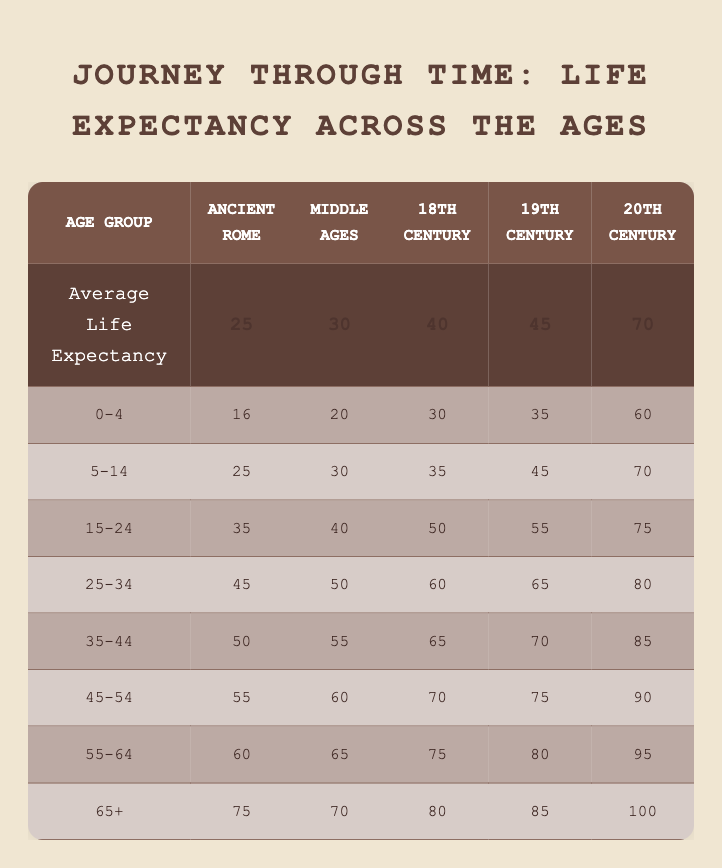What was the average life expectancy in the 20th century? The table states that the average life expectancy for the 20th century is 70.
Answer: 70 How long could someone expect to live at age 65 in the Middle Ages? According to the table, a person aged 65 and older in the Middle Ages had a life expectancy of 70 years.
Answer: 70 Which age group saw the largest increase in life expectancy from Ancient Rome to the 20th century? By comparing the values, the age group 65+ had a life expectancy of 75 in Ancient Rome and 100 in the 20th century. The increase is 100 - 75 = 25 years, which is the largest increase compared to other age groups.
Answer: 65+ What is the difference in life expectancy for the age group 5-14 between the 18th and 19th centuries? The life expectancy for the age group 5-14 is 35 in the 18th century and 45 in the 19th century. The difference is 45 - 35 = 10 years.
Answer: 10 Is the life expectancy for the age group 55-64 in the 19th century higher than that in the Middle Ages? The life expectancy for the age group 55-64 in the 19th century is 80, while in the Middle Ages it is 65. Since 80 is greater than 65, the statement is true.
Answer: Yes What is the average life expectancy across all periods for the age group 25-34? For this age group, the life expectancies are 45 (Ancient Rome), 50 (Middle Ages), 60 (18th century), 65 (19th century), and 80 (20th century). The average is (45 + 50 + 60 + 65 + 80) / 5 = 60.
Answer: 60 In which historical period did the 15-24 age group have a life expectancy closest to 50 years? The life expectancy for the 15-24 age group is 50 in the 18th century and 55 in the 19th century. Since 50 is the only value closest to 50, it corresponds to the 18th century.
Answer: 18th century What was the average life expectancy for individuals aged 0-4 across all historical periods? The life expectancies for the age group 0-4 are 16 (Ancient Rome), 20 (Middle Ages), 30 (18th century), 35 (19th century), and 60 (20th century). The average is (16 + 20 + 30 + 35 + 60) / 5 = 32.2, which rounds to approximately 32.
Answer: 32.2 